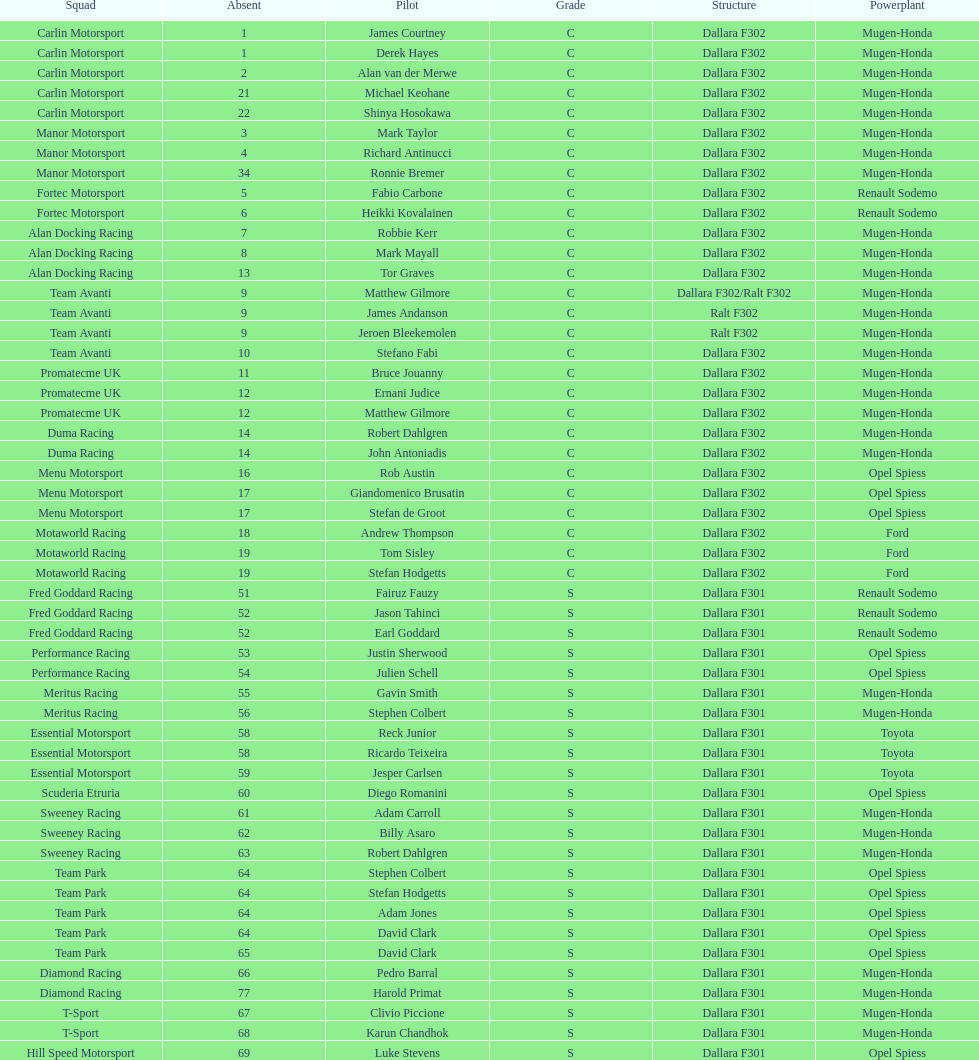Who had more drivers, team avanti or motaworld racing? Team Avanti. 